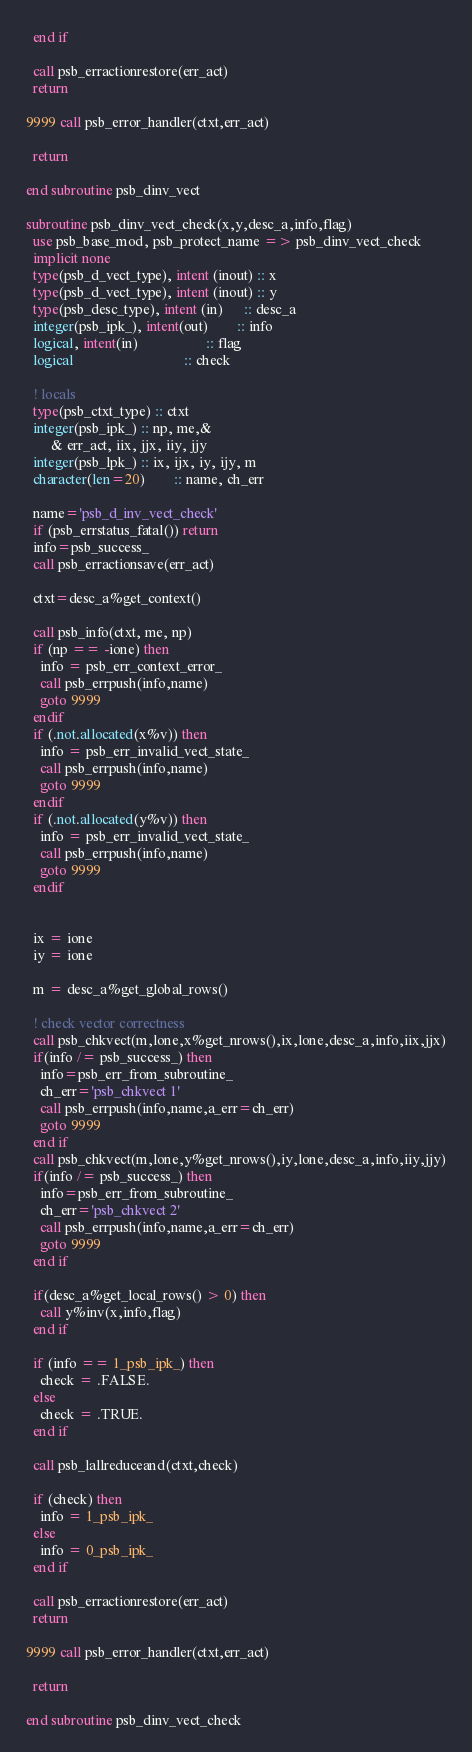<code> <loc_0><loc_0><loc_500><loc_500><_FORTRAN_>  end if

  call psb_erractionrestore(err_act)
  return

9999 call psb_error_handler(ctxt,err_act)

  return

end subroutine psb_dinv_vect

subroutine psb_dinv_vect_check(x,y,desc_a,info,flag)
  use psb_base_mod, psb_protect_name => psb_dinv_vect_check
  implicit none
  type(psb_d_vect_type), intent (inout) :: x
  type(psb_d_vect_type), intent (inout) :: y
  type(psb_desc_type), intent (in)      :: desc_a
  integer(psb_ipk_), intent(out)        :: info
  logical, intent(in)                   :: flag
  logical                               :: check

  ! locals
  type(psb_ctxt_type) :: ctxt
  integer(psb_ipk_) :: np, me,&
       & err_act, iix, jjx, iiy, jjy
  integer(psb_lpk_) :: ix, ijx, iy, ijy, m
  character(len=20)        :: name, ch_err

  name='psb_d_inv_vect_check'
  if (psb_errstatus_fatal()) return
  info=psb_success_
  call psb_erractionsave(err_act)

  ctxt=desc_a%get_context()

  call psb_info(ctxt, me, np)
  if (np == -ione) then
    info = psb_err_context_error_
    call psb_errpush(info,name)
    goto 9999
  endif
  if (.not.allocated(x%v)) then
    info = psb_err_invalid_vect_state_
    call psb_errpush(info,name)
    goto 9999
  endif
  if (.not.allocated(y%v)) then
    info = psb_err_invalid_vect_state_
    call psb_errpush(info,name)
    goto 9999
  endif


  ix = ione
  iy = ione

  m = desc_a%get_global_rows()

  ! check vector correctness
  call psb_chkvect(m,lone,x%get_nrows(),ix,lone,desc_a,info,iix,jjx)
  if(info /= psb_success_) then
    info=psb_err_from_subroutine_
    ch_err='psb_chkvect 1'
    call psb_errpush(info,name,a_err=ch_err)
    goto 9999
  end if
  call psb_chkvect(m,lone,y%get_nrows(),iy,lone,desc_a,info,iiy,jjy)
  if(info /= psb_success_) then
    info=psb_err_from_subroutine_
    ch_err='psb_chkvect 2'
    call psb_errpush(info,name,a_err=ch_err)
    goto 9999
  end if

  if(desc_a%get_local_rows() > 0) then
    call y%inv(x,info,flag)
  end if

  if (info == 1_psb_ipk_) then
    check = .FALSE.
  else
    check = .TRUE.
  end if

  call psb_lallreduceand(ctxt,check)

  if (check) then
    info = 1_psb_ipk_
  else
    info = 0_psb_ipk_
  end if

  call psb_erractionrestore(err_act)
  return

9999 call psb_error_handler(ctxt,err_act)

  return

end subroutine psb_dinv_vect_check
</code> 